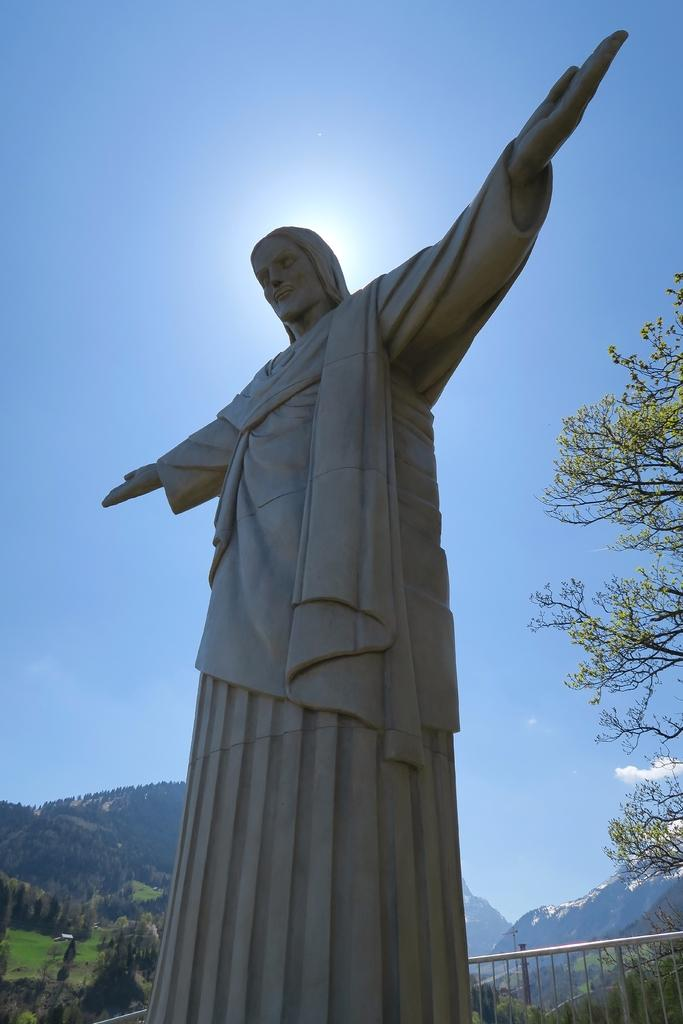What is the main subject in the foreground of the picture? There is a sculpture in the foreground of the picture. What can be seen in the background of the picture? There are trees and mountains in the background of the picture. What is visible at the top of the image? The sky is visible at the top of the image. Can the sun be seen in the sky? Yes, the sun is observable in the sky. What type of society is depicted in the library in the image? There is no library or society present in the image; it features a sculpture, trees, mountains, sky, and the sun. 